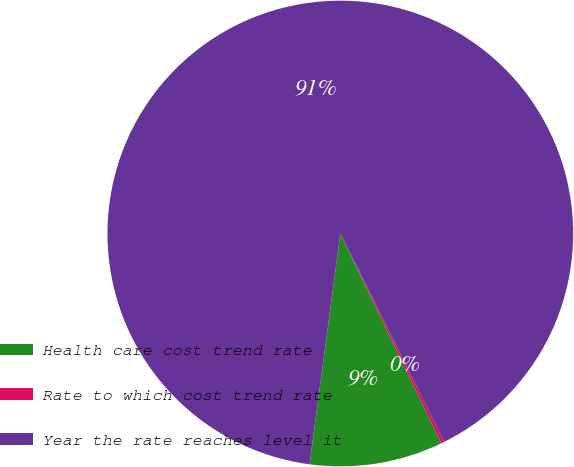Convert chart. <chart><loc_0><loc_0><loc_500><loc_500><pie_chart><fcel>Health care cost trend rate<fcel>Rate to which cost trend rate<fcel>Year the rate reaches level it<nl><fcel>9.25%<fcel>0.22%<fcel>90.52%<nl></chart> 